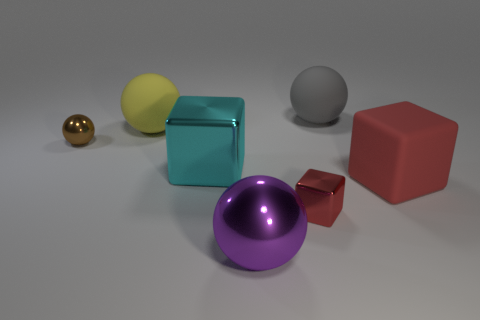Subtract all brown spheres. How many spheres are left? 3 Add 1 small blue rubber cylinders. How many objects exist? 8 Subtract all gray spheres. How many spheres are left? 3 Add 5 red shiny cubes. How many red shiny cubes exist? 6 Subtract 0 blue cylinders. How many objects are left? 7 Subtract all blocks. How many objects are left? 4 Subtract 4 spheres. How many spheres are left? 0 Subtract all brown spheres. Subtract all gray cylinders. How many spheres are left? 3 Subtract all purple blocks. How many red balls are left? 0 Subtract all yellow matte things. Subtract all big cyan objects. How many objects are left? 5 